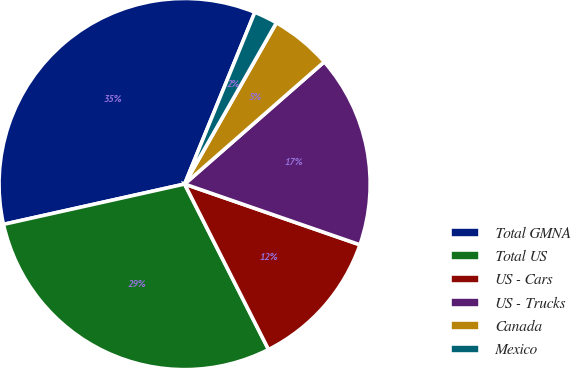<chart> <loc_0><loc_0><loc_500><loc_500><pie_chart><fcel>Total GMNA<fcel>Total US<fcel>US - Cars<fcel>US - Trucks<fcel>Canada<fcel>Mexico<nl><fcel>34.66%<fcel>28.98%<fcel>12.22%<fcel>16.75%<fcel>5.32%<fcel>2.06%<nl></chart> 